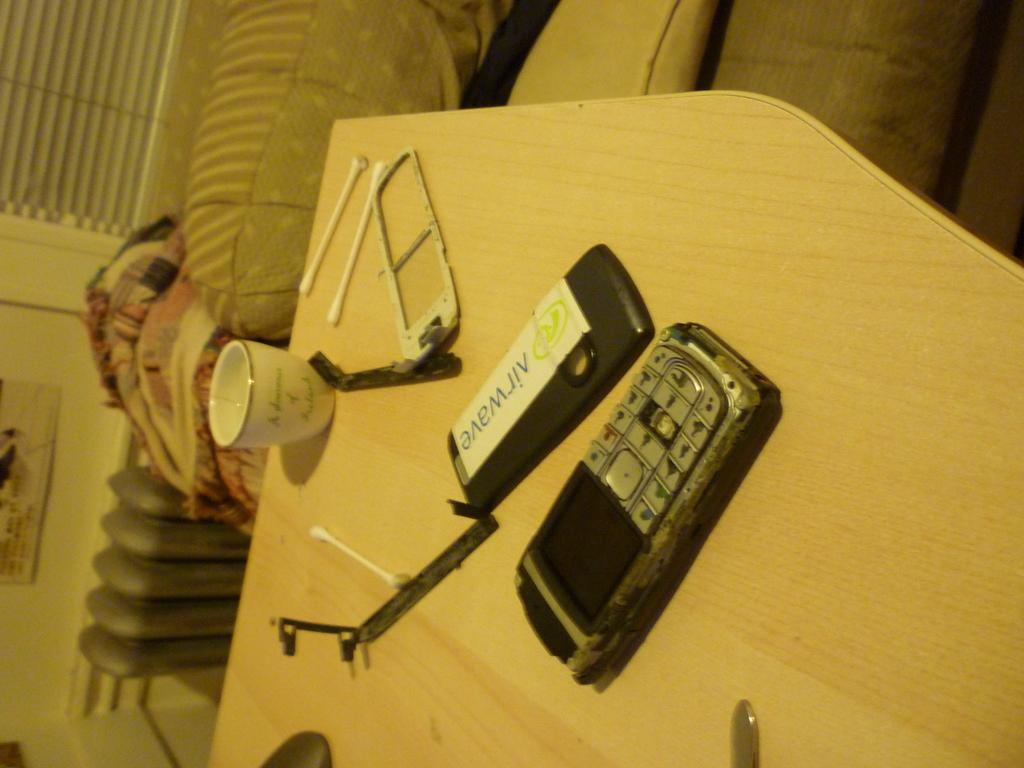<image>
Present a compact description of the photo's key features. The removed back of a phone with a sticker that says AirWave on it is on a wooden table next to the phone. 